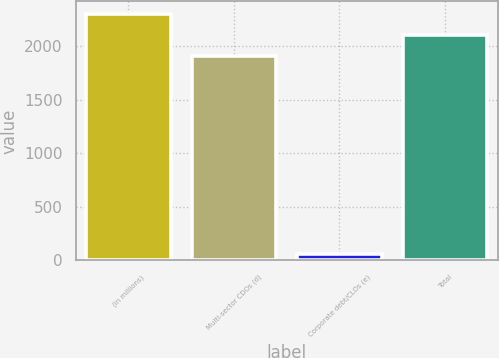Convert chart. <chart><loc_0><loc_0><loc_500><loc_500><bar_chart><fcel>(in millions)<fcel>Multi-sector CDOs (d)<fcel>Corporate debt/CLOs (e)<fcel>Total<nl><fcel>2300.4<fcel>1910<fcel>60<fcel>2105.2<nl></chart> 